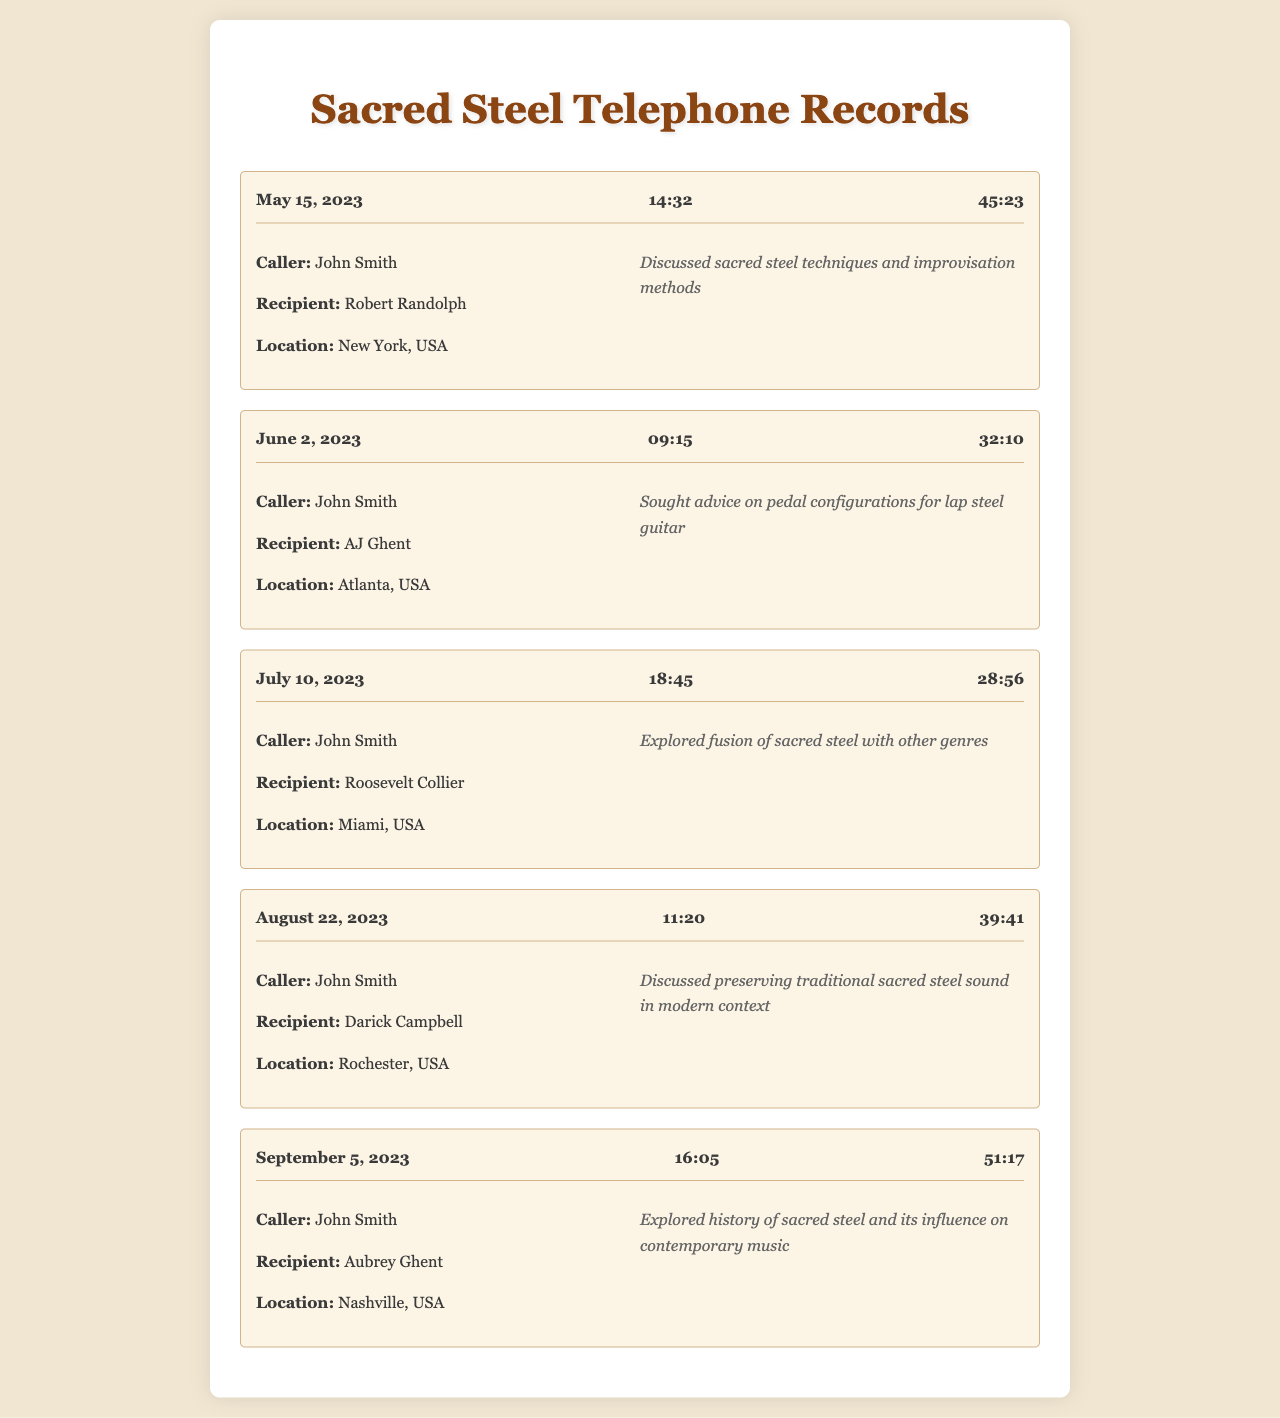What is the date of the call with Robert Randolph? The date of the call with Robert Randolph is May 15, 2023.
Answer: May 15, 2023 How long was the call with AJ Ghent? The duration of the call with AJ Ghent was 32 minutes and 10 seconds.
Answer: 32:10 Who was the recipient of the call on July 10, 2023? The recipient of the call on July 10, 2023, was Roosevelt Collier.
Answer: Roosevelt Collier What was discussed during the call with Darick Campbell? The call with Darick Campbell discussed preserving traditional sacred steel sound in modern context.
Answer: Preserving traditional sacred steel sound in modern context Which location was John Smith in when he called Aubrey Ghent? John Smith was in Nashville, USA when he called Aubrey Ghent.
Answer: Nashville, USA How many calls did John Smith make for mentorship? John Smith made five calls for mentorship.
Answer: Five What common theme was discussed during calls with lap steel guitarists? A common theme during the calls was the exploration and preservation of sacred steel music.
Answer: Exploration and preservation of sacred steel music Which lap steel guitarist did John Smith call first? The first lap steel guitarist John Smith called was Robert Randolph.
Answer: Robert Randolph What was the location of the call to AJ Ghent? The location of the call to AJ Ghent was Atlanta, USA.
Answer: Atlanta, USA 